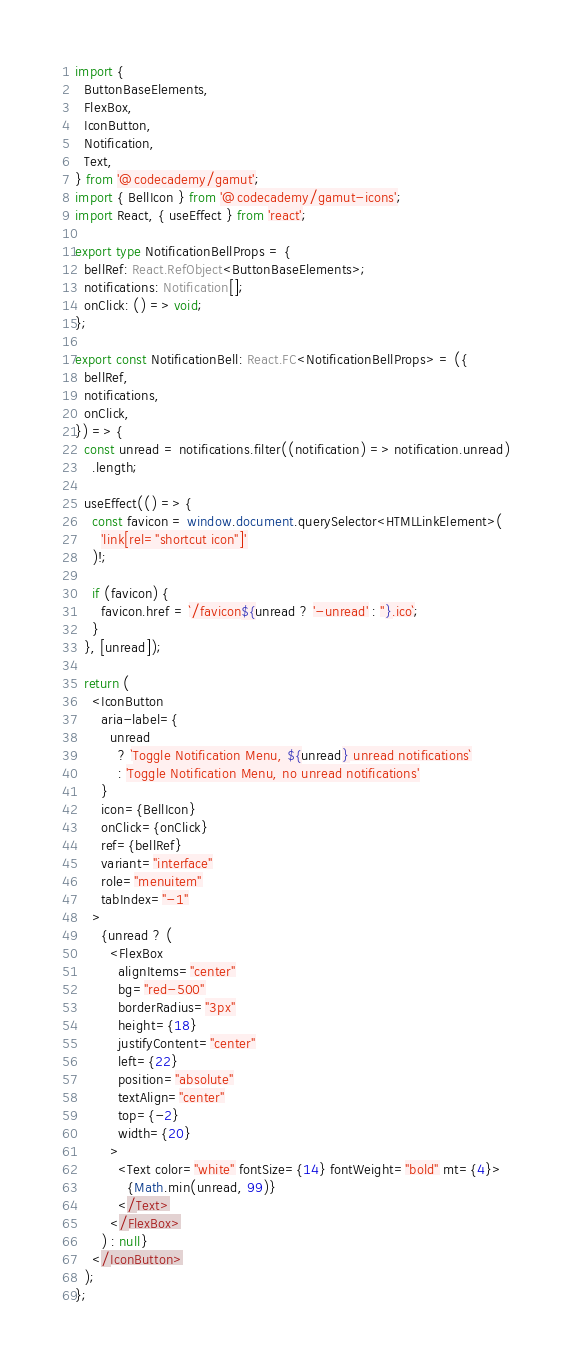<code> <loc_0><loc_0><loc_500><loc_500><_TypeScript_>import {
  ButtonBaseElements,
  FlexBox,
  IconButton,
  Notification,
  Text,
} from '@codecademy/gamut';
import { BellIcon } from '@codecademy/gamut-icons';
import React, { useEffect } from 'react';

export type NotificationBellProps = {
  bellRef: React.RefObject<ButtonBaseElements>;
  notifications: Notification[];
  onClick: () => void;
};

export const NotificationBell: React.FC<NotificationBellProps> = ({
  bellRef,
  notifications,
  onClick,
}) => {
  const unread = notifications.filter((notification) => notification.unread)
    .length;

  useEffect(() => {
    const favicon = window.document.querySelector<HTMLLinkElement>(
      'link[rel="shortcut icon"]'
    )!;

    if (favicon) {
      favicon.href = `/favicon${unread ? '-unread' : ''}.ico`;
    }
  }, [unread]);

  return (
    <IconButton
      aria-label={
        unread
          ? `Toggle Notification Menu, ${unread} unread notifications`
          : 'Toggle Notification Menu, no unread notifications'
      }
      icon={BellIcon}
      onClick={onClick}
      ref={bellRef}
      variant="interface"
      role="menuitem"
      tabIndex="-1"
    >
      {unread ? (
        <FlexBox
          alignItems="center"
          bg="red-500"
          borderRadius="3px"
          height={18}
          justifyContent="center"
          left={22}
          position="absolute"
          textAlign="center"
          top={-2}
          width={20}
        >
          <Text color="white" fontSize={14} fontWeight="bold" mt={4}>
            {Math.min(unread, 99)}
          </Text>
        </FlexBox>
      ) : null}
    </IconButton>
  );
};
</code> 